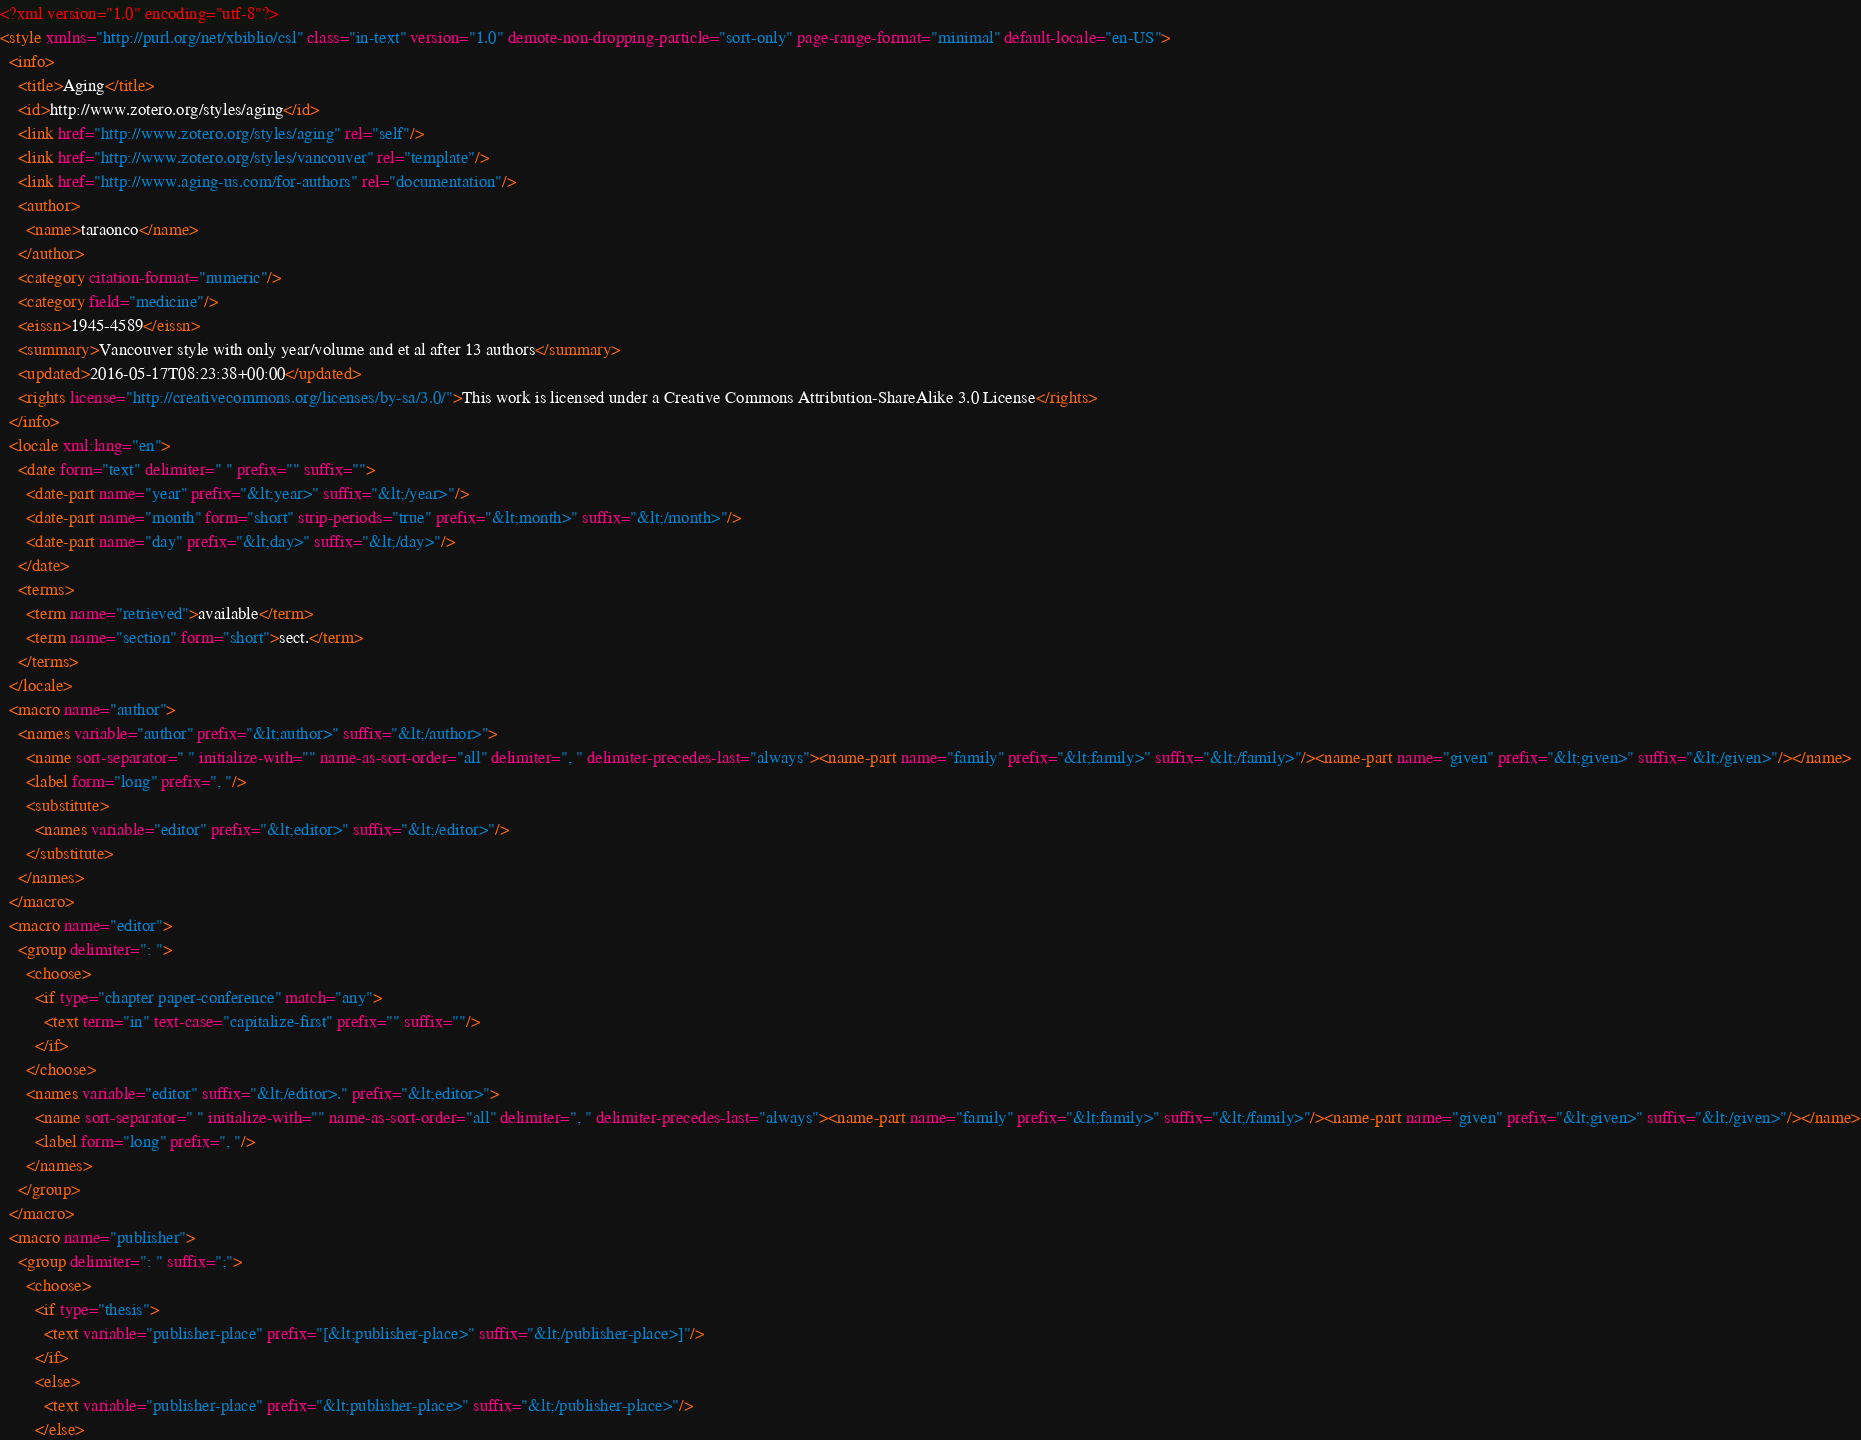Convert code to text. <code><loc_0><loc_0><loc_500><loc_500><_XML_><?xml version="1.0" encoding="utf-8"?>
<style xmlns="http://purl.org/net/xbiblio/csl" class="in-text" version="1.0" demote-non-dropping-particle="sort-only" page-range-format="minimal" default-locale="en-US">
  <info>
    <title>Aging</title>
    <id>http://www.zotero.org/styles/aging</id>
    <link href="http://www.zotero.org/styles/aging" rel="self"/>
    <link href="http://www.zotero.org/styles/vancouver" rel="template"/>
    <link href="http://www.aging-us.com/for-authors" rel="documentation"/>
    <author>
      <name>taraonco</name>
    </author>
    <category citation-format="numeric"/>
    <category field="medicine"/>
    <eissn>1945-4589</eissn>
    <summary>Vancouver style with only year/volume and et al after 13 authors</summary>
    <updated>2016-05-17T08:23:38+00:00</updated>
    <rights license="http://creativecommons.org/licenses/by-sa/3.0/">This work is licensed under a Creative Commons Attribution-ShareAlike 3.0 License</rights>
  </info>
  <locale xml:lang="en">
    <date form="text" delimiter=" " prefix="" suffix="">
      <date-part name="year" prefix="&lt;year>" suffix="&lt;/year>"/>
      <date-part name="month" form="short" strip-periods="true" prefix="&lt;month>" suffix="&lt;/month>"/>
      <date-part name="day" prefix="&lt;day>" suffix="&lt;/day>"/>
    </date>
    <terms>
      <term name="retrieved">available</term>
      <term name="section" form="short">sect.</term>
    </terms>
  </locale>
  <macro name="author">
    <names variable="author" prefix="&lt;author>" suffix="&lt;/author>">
      <name sort-separator=" " initialize-with="" name-as-sort-order="all" delimiter=", " delimiter-precedes-last="always"><name-part name="family" prefix="&lt;family>" suffix="&lt;/family>"/><name-part name="given" prefix="&lt;given>" suffix="&lt;/given>"/></name>
      <label form="long" prefix=", "/>
      <substitute>
        <names variable="editor" prefix="&lt;editor>" suffix="&lt;/editor>"/>
      </substitute>
    </names>
  </macro>
  <macro name="editor">
    <group delimiter=": ">
      <choose>
        <if type="chapter paper-conference" match="any">
          <text term="in" text-case="capitalize-first" prefix="" suffix=""/>
        </if>
      </choose>
      <names variable="editor" suffix="&lt;/editor>." prefix="&lt;editor>">
        <name sort-separator=" " initialize-with="" name-as-sort-order="all" delimiter=", " delimiter-precedes-last="always"><name-part name="family" prefix="&lt;family>" suffix="&lt;/family>"/><name-part name="given" prefix="&lt;given>" suffix="&lt;/given>"/></name>
        <label form="long" prefix=", "/>
      </names>
    </group>
  </macro>
  <macro name="publisher">
    <group delimiter=": " suffix=";">
      <choose>
        <if type="thesis">
          <text variable="publisher-place" prefix="[&lt;publisher-place>" suffix="&lt;/publisher-place>]"/>
        </if>
        <else>
          <text variable="publisher-place" prefix="&lt;publisher-place>" suffix="&lt;/publisher-place>"/>
        </else></code> 